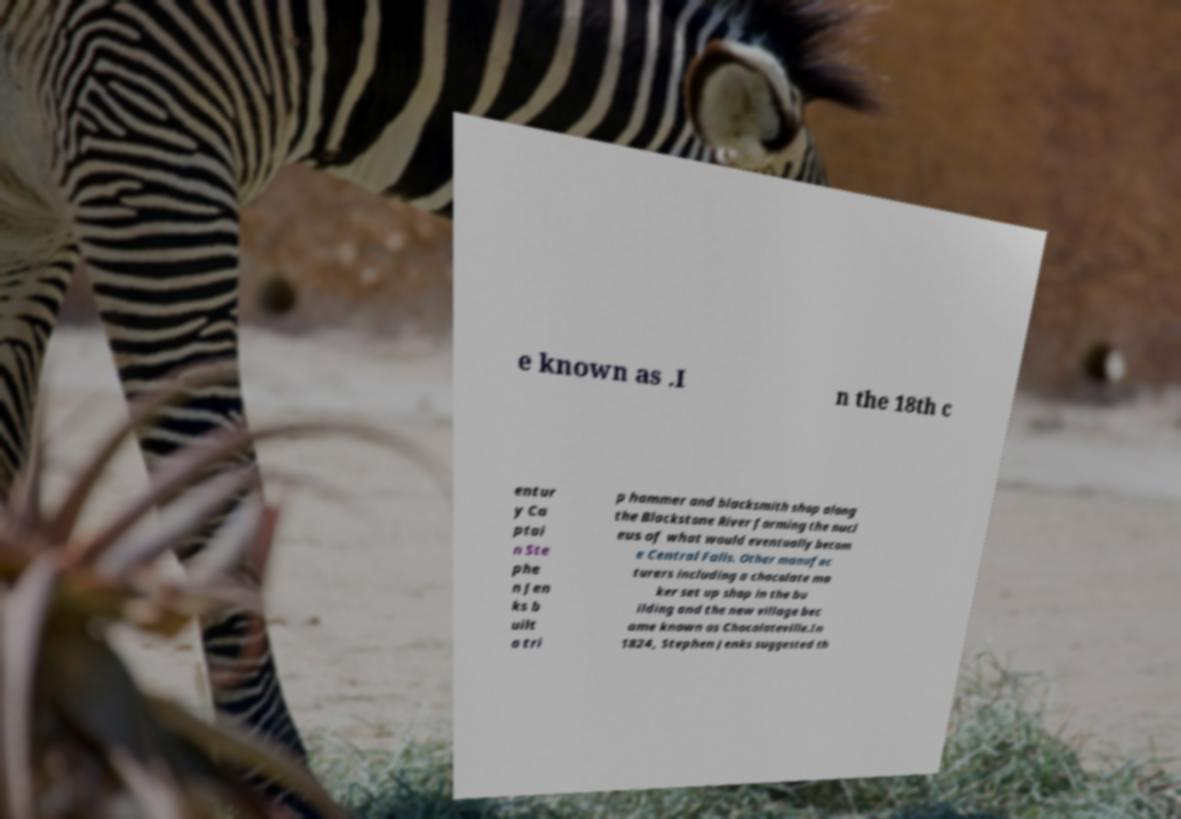I need the written content from this picture converted into text. Can you do that? e known as .I n the 18th c entur y Ca ptai n Ste phe n Jen ks b uilt a tri p hammer and blacksmith shop along the Blackstone River forming the nucl eus of what would eventually becom e Central Falls. Other manufac turers including a chocolate ma ker set up shop in the bu ilding and the new village bec ame known as Chocolateville.In 1824, Stephen Jenks suggested th 